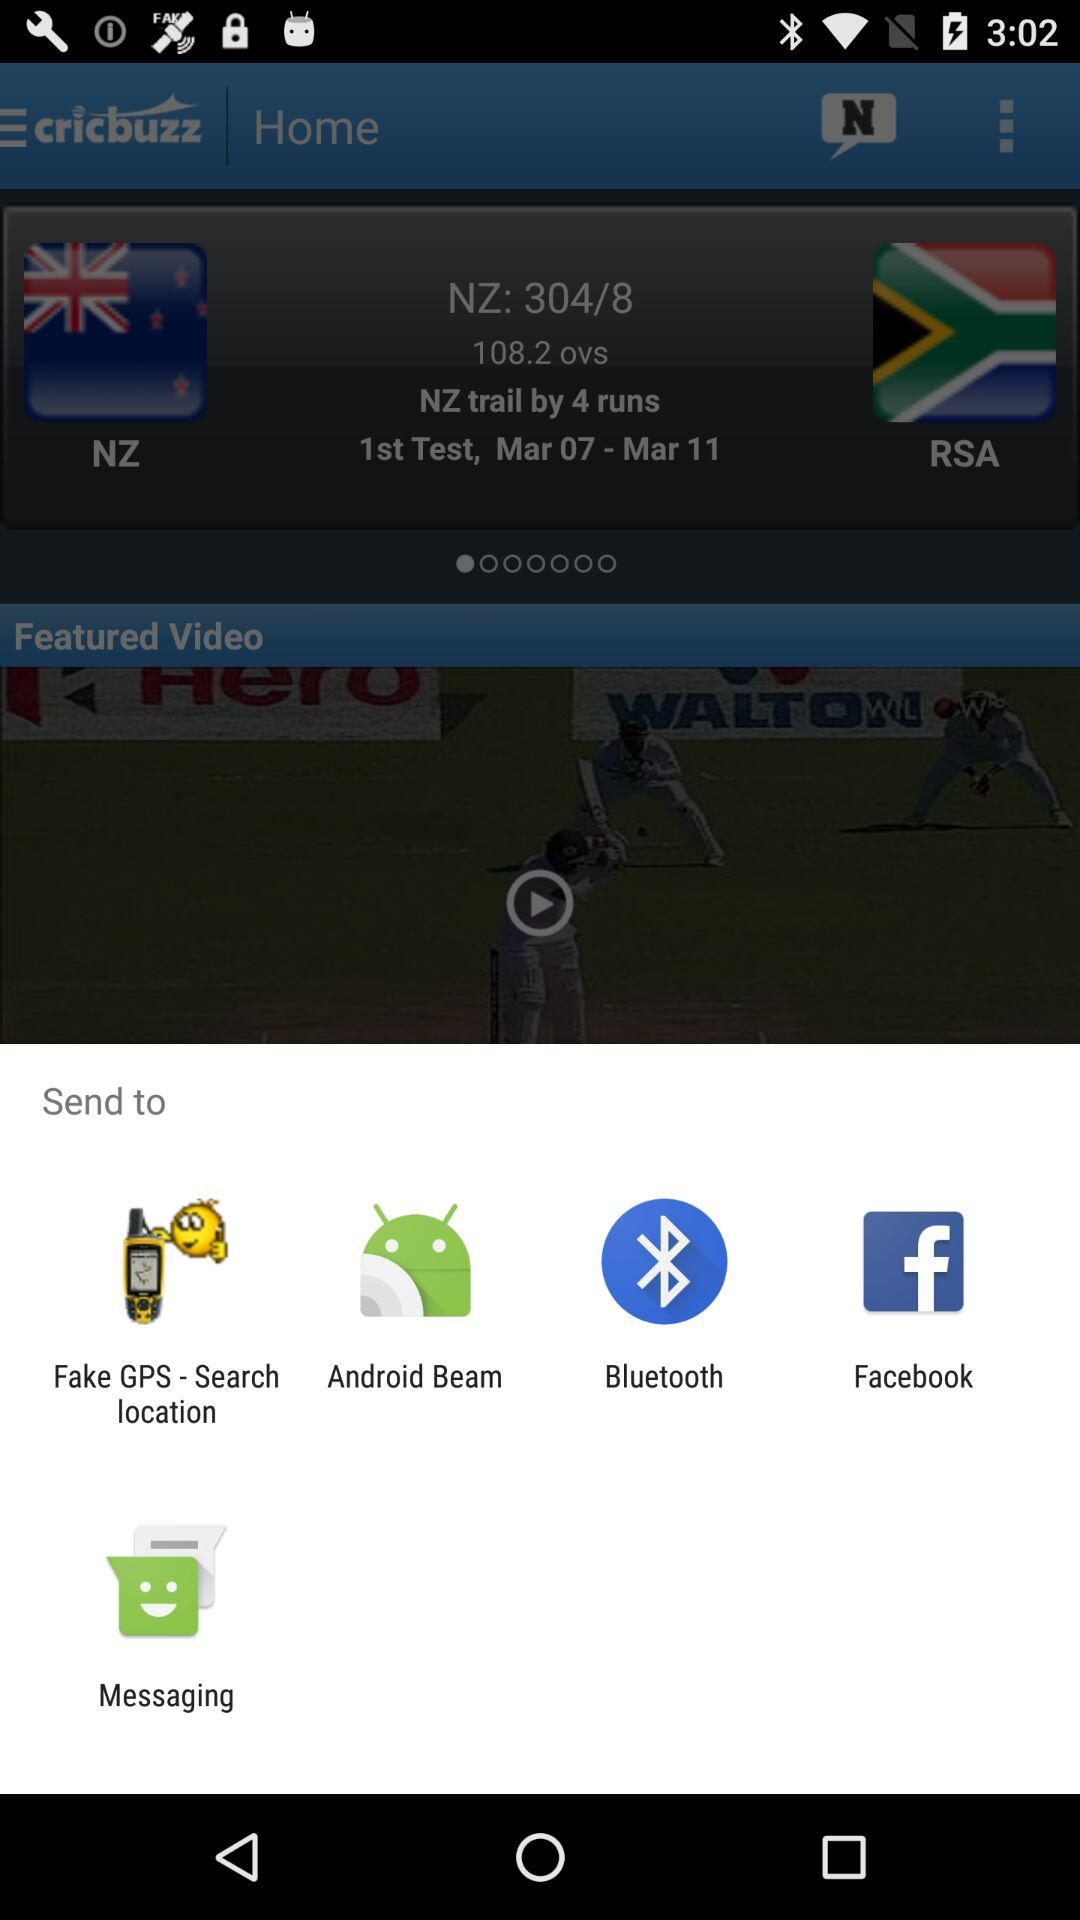Which application can be used to share? The applications "Fake GPS - Search location", "Android Beam", "Bluetooth", "Facebook" and "Messaging" can be used to share. 